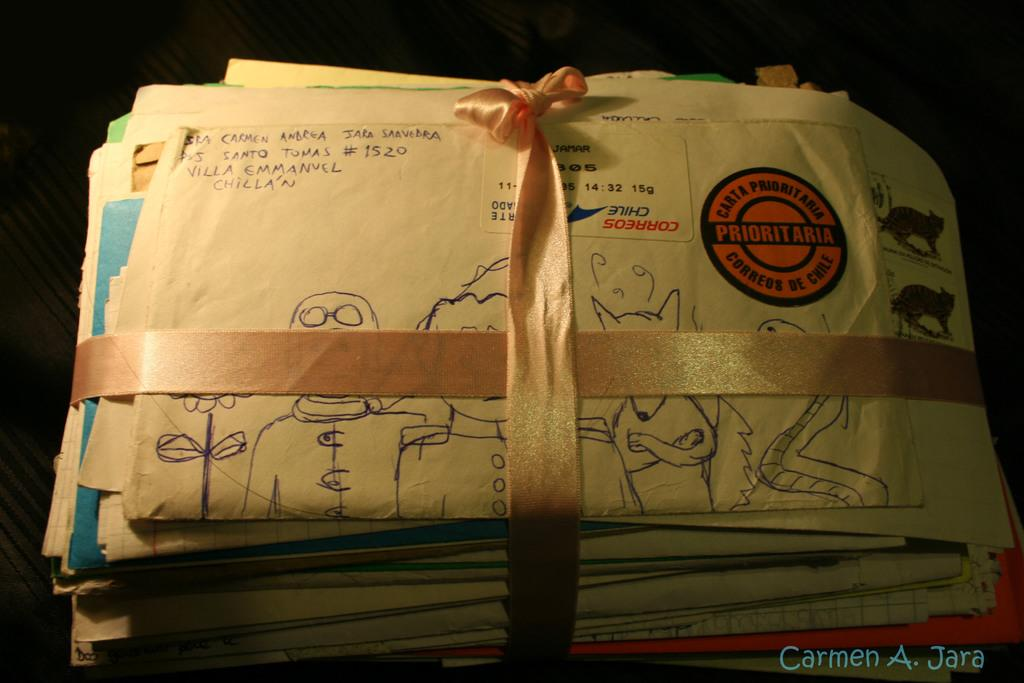Provide a one-sentence caption for the provided image. A stack of letters is tied with a ribbon, the top letter has a return address of Santo Tomas #1520, Villa Emmanuel Chillain. 